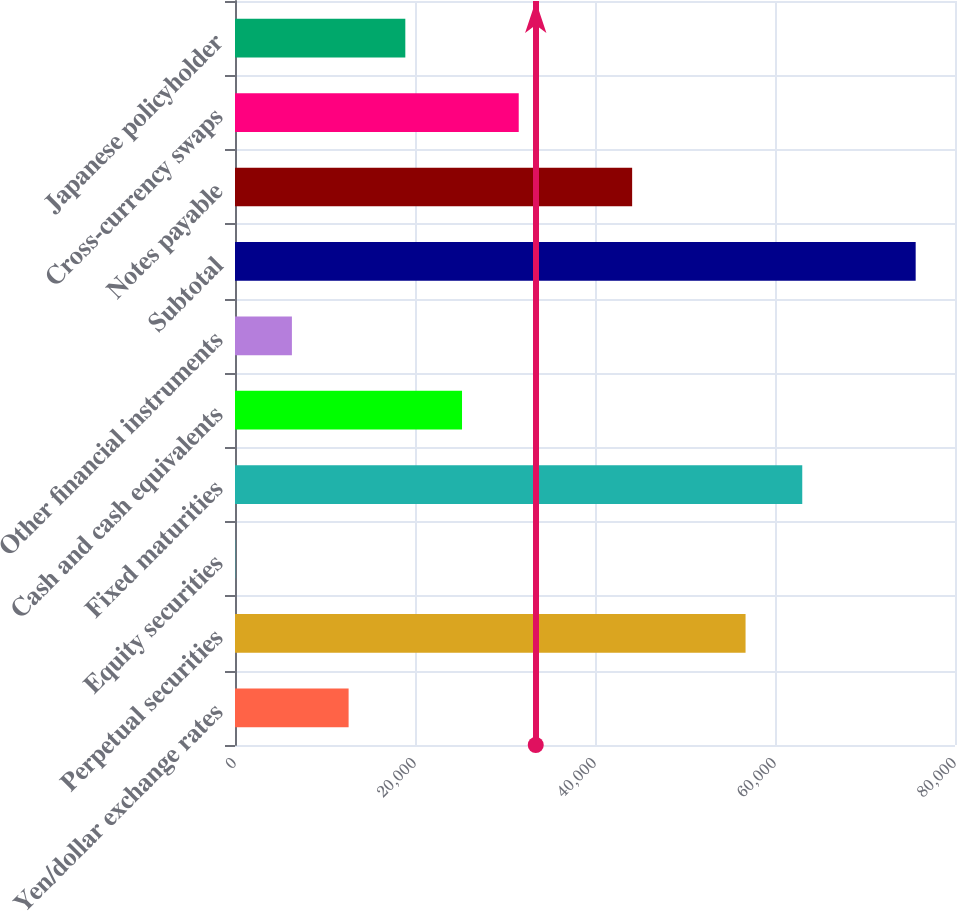Convert chart to OTSL. <chart><loc_0><loc_0><loc_500><loc_500><bar_chart><fcel>Yen/dollar exchange rates<fcel>Perpetual securities<fcel>Equity securities<fcel>Fixed maturities<fcel>Cash and cash equivalents<fcel>Other financial instruments<fcel>Subtotal<fcel>Notes payable<fcel>Cross-currency swaps<fcel>Japanese policyholder<nl><fcel>12623.4<fcel>56728.3<fcel>22<fcel>63029<fcel>25224.8<fcel>6322.7<fcel>75630.4<fcel>44126.9<fcel>31525.5<fcel>18924.1<nl></chart> 